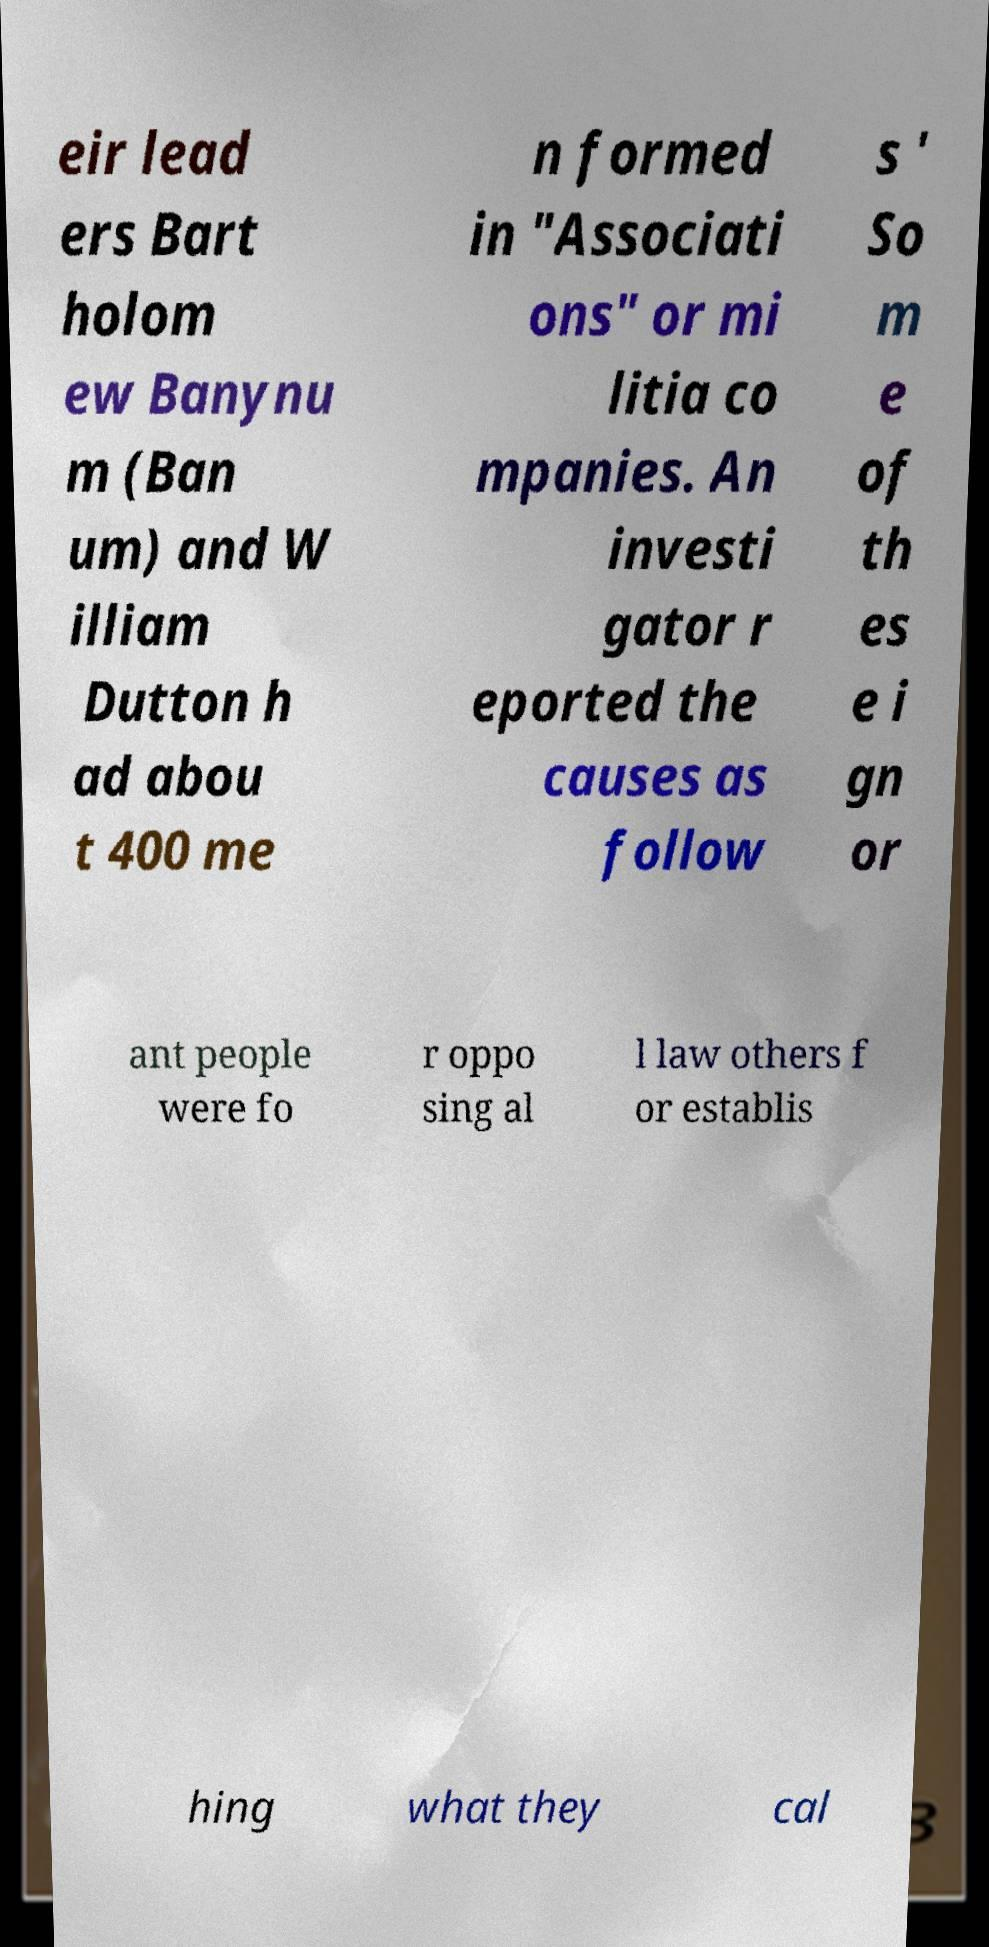For documentation purposes, I need the text within this image transcribed. Could you provide that? eir lead ers Bart holom ew Banynu m (Ban um) and W illiam Dutton h ad abou t 400 me n formed in "Associati ons" or mi litia co mpanies. An investi gator r eported the causes as follow s ' So m e of th es e i gn or ant people were fo r oppo sing al l law others f or establis hing what they cal 